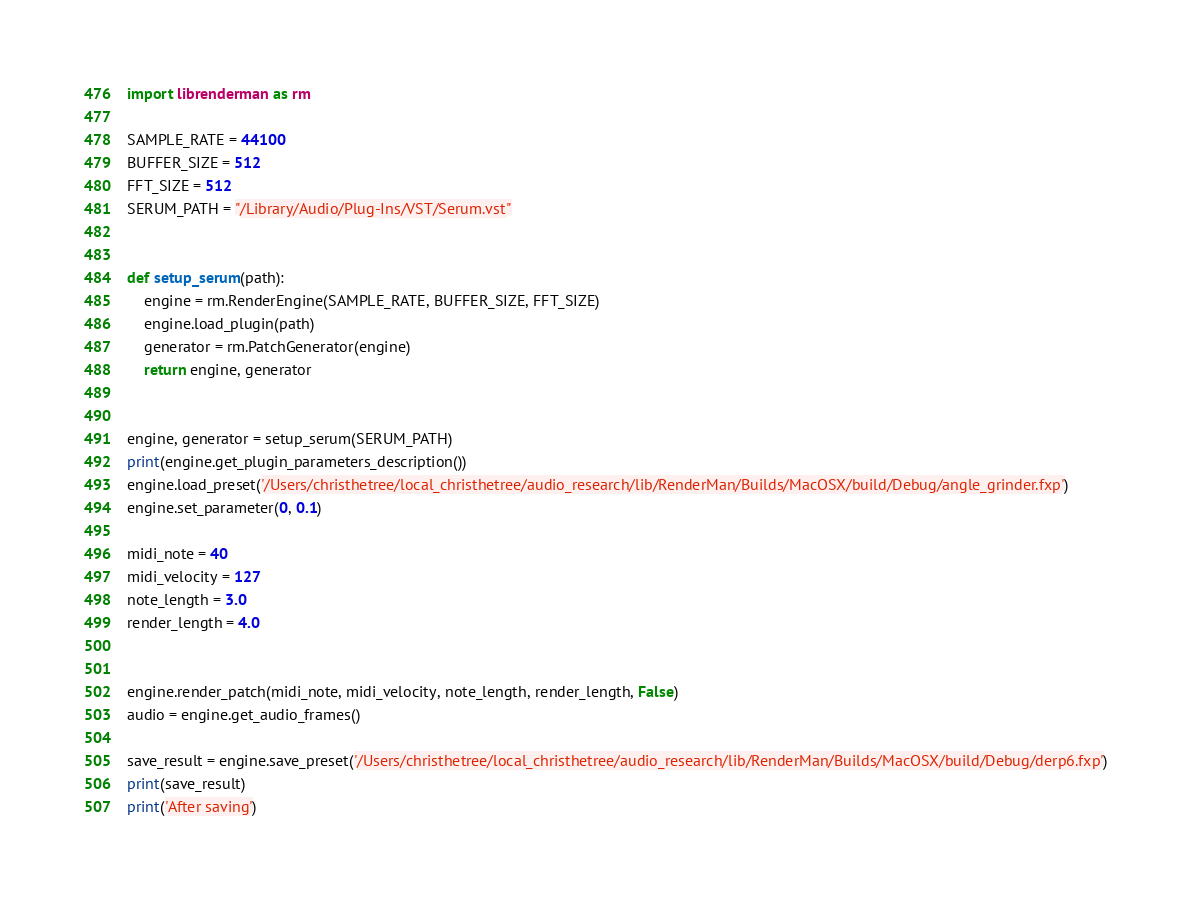<code> <loc_0><loc_0><loc_500><loc_500><_Python_>import librenderman as rm

SAMPLE_RATE = 44100
BUFFER_SIZE = 512
FFT_SIZE = 512
SERUM_PATH = "/Library/Audio/Plug-Ins/VST/Serum.vst"


def setup_serum(path):
    engine = rm.RenderEngine(SAMPLE_RATE, BUFFER_SIZE, FFT_SIZE)
    engine.load_plugin(path)
    generator = rm.PatchGenerator(engine)
    return engine, generator


engine, generator = setup_serum(SERUM_PATH)
print(engine.get_plugin_parameters_description())
engine.load_preset('/Users/christhetree/local_christhetree/audio_research/lib/RenderMan/Builds/MacOSX/build/Debug/angle_grinder.fxp')
engine.set_parameter(0, 0.1)

midi_note = 40
midi_velocity = 127
note_length = 3.0
render_length = 4.0


engine.render_patch(midi_note, midi_velocity, note_length, render_length, False)
audio = engine.get_audio_frames()

save_result = engine.save_preset('/Users/christhetree/local_christhetree/audio_research/lib/RenderMan/Builds/MacOSX/build/Debug/derp6.fxp')
print(save_result)
print('After saving')
</code> 